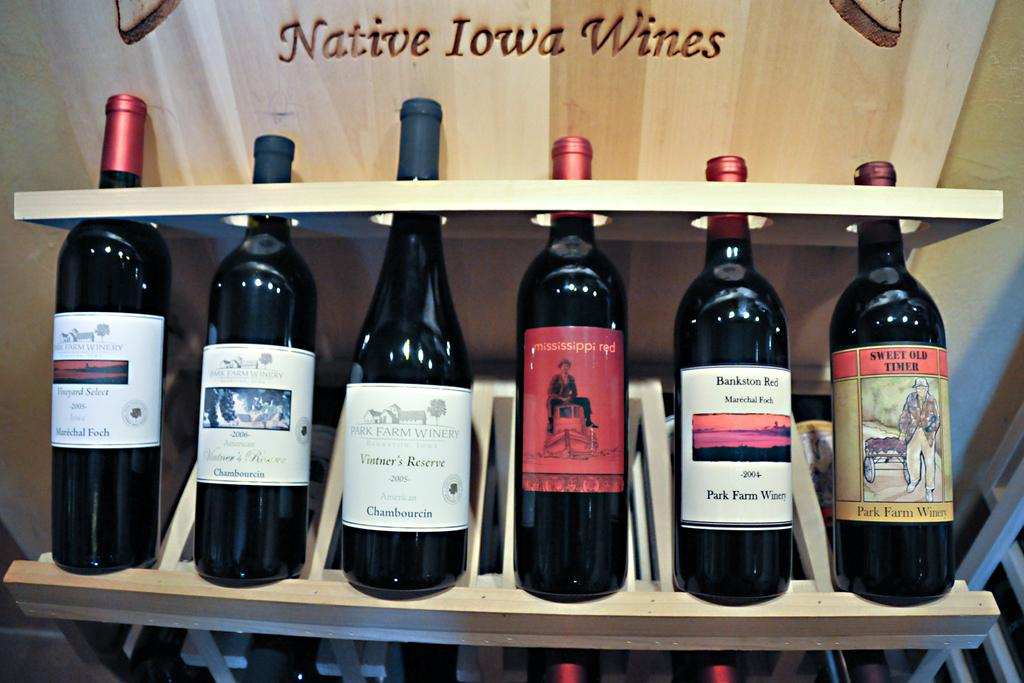<image>
Create a compact narrative representing the image presented. Six bottle of wine with the words Native Iowa wines over them. 